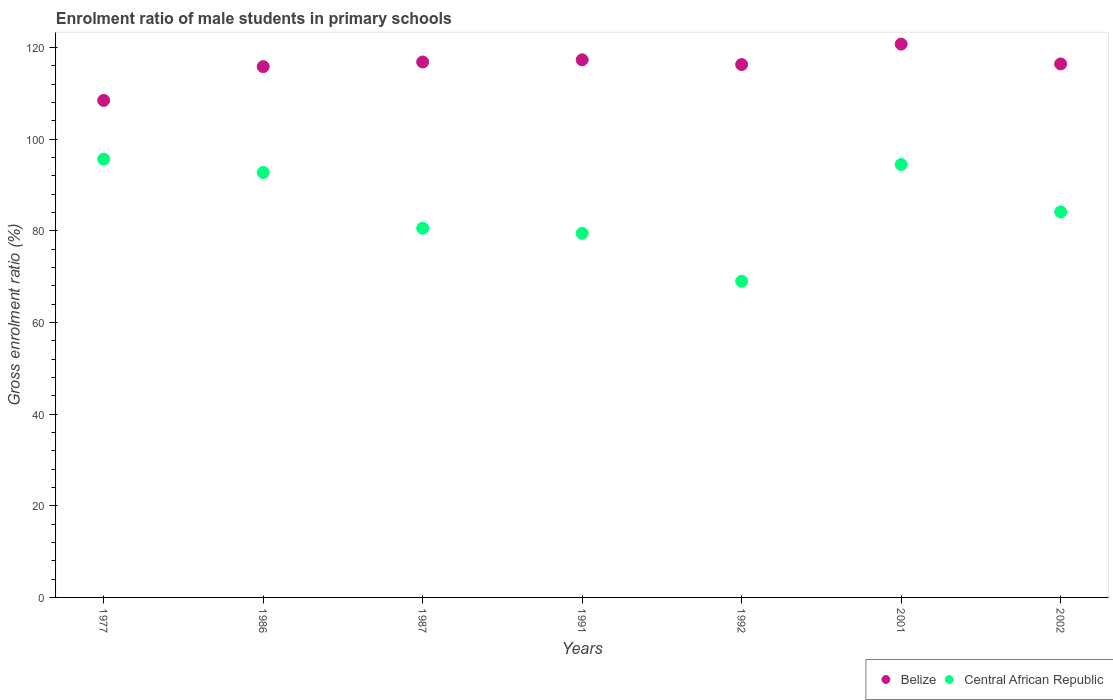What is the enrolment ratio of male students in primary schools in Belize in 2002?
Your answer should be compact. 116.45. Across all years, what is the maximum enrolment ratio of male students in primary schools in Central African Republic?
Make the answer very short. 95.67. Across all years, what is the minimum enrolment ratio of male students in primary schools in Belize?
Your answer should be compact. 108.48. In which year was the enrolment ratio of male students in primary schools in Central African Republic minimum?
Make the answer very short. 1992. What is the total enrolment ratio of male students in primary schools in Central African Republic in the graph?
Your answer should be very brief. 596.15. What is the difference between the enrolment ratio of male students in primary schools in Central African Republic in 1987 and that in 2002?
Offer a terse response. -3.56. What is the difference between the enrolment ratio of male students in primary schools in Belize in 1991 and the enrolment ratio of male students in primary schools in Central African Republic in 1992?
Offer a very short reply. 48.32. What is the average enrolment ratio of male students in primary schools in Belize per year?
Give a very brief answer. 116.01. In the year 1977, what is the difference between the enrolment ratio of male students in primary schools in Central African Republic and enrolment ratio of male students in primary schools in Belize?
Offer a terse response. -12.81. In how many years, is the enrolment ratio of male students in primary schools in Central African Republic greater than 52 %?
Make the answer very short. 7. What is the ratio of the enrolment ratio of male students in primary schools in Central African Republic in 1992 to that in 2001?
Provide a short and direct response. 0.73. What is the difference between the highest and the second highest enrolment ratio of male students in primary schools in Central African Republic?
Provide a short and direct response. 1.17. What is the difference between the highest and the lowest enrolment ratio of male students in primary schools in Central African Republic?
Ensure brevity in your answer.  26.65. In how many years, is the enrolment ratio of male students in primary schools in Central African Republic greater than the average enrolment ratio of male students in primary schools in Central African Republic taken over all years?
Ensure brevity in your answer.  3. Does the enrolment ratio of male students in primary schools in Belize monotonically increase over the years?
Offer a terse response. No. Is the enrolment ratio of male students in primary schools in Belize strictly less than the enrolment ratio of male students in primary schools in Central African Republic over the years?
Offer a terse response. No. How many dotlines are there?
Offer a very short reply. 2. Are the values on the major ticks of Y-axis written in scientific E-notation?
Make the answer very short. No. Does the graph contain any zero values?
Make the answer very short. No. What is the title of the graph?
Your answer should be very brief. Enrolment ratio of male students in primary schools. Does "Singapore" appear as one of the legend labels in the graph?
Your answer should be compact. No. What is the label or title of the X-axis?
Your answer should be very brief. Years. What is the label or title of the Y-axis?
Your answer should be very brief. Gross enrolment ratio (%). What is the Gross enrolment ratio (%) in Belize in 1977?
Your response must be concise. 108.48. What is the Gross enrolment ratio (%) of Central African Republic in 1977?
Your response must be concise. 95.67. What is the Gross enrolment ratio (%) of Belize in 1986?
Your response must be concise. 115.86. What is the Gross enrolment ratio (%) of Central African Republic in 1986?
Keep it short and to the point. 92.75. What is the Gross enrolment ratio (%) in Belize in 1987?
Keep it short and to the point. 116.87. What is the Gross enrolment ratio (%) of Central African Republic in 1987?
Your response must be concise. 80.58. What is the Gross enrolment ratio (%) in Belize in 1991?
Make the answer very short. 117.34. What is the Gross enrolment ratio (%) in Central African Republic in 1991?
Your answer should be very brief. 79.48. What is the Gross enrolment ratio (%) of Belize in 1992?
Provide a short and direct response. 116.31. What is the Gross enrolment ratio (%) in Central African Republic in 1992?
Make the answer very short. 69.02. What is the Gross enrolment ratio (%) of Belize in 2001?
Offer a very short reply. 120.77. What is the Gross enrolment ratio (%) of Central African Republic in 2001?
Your answer should be compact. 94.5. What is the Gross enrolment ratio (%) in Belize in 2002?
Keep it short and to the point. 116.45. What is the Gross enrolment ratio (%) of Central African Republic in 2002?
Your response must be concise. 84.15. Across all years, what is the maximum Gross enrolment ratio (%) in Belize?
Give a very brief answer. 120.77. Across all years, what is the maximum Gross enrolment ratio (%) of Central African Republic?
Make the answer very short. 95.67. Across all years, what is the minimum Gross enrolment ratio (%) in Belize?
Your answer should be compact. 108.48. Across all years, what is the minimum Gross enrolment ratio (%) of Central African Republic?
Your answer should be very brief. 69.02. What is the total Gross enrolment ratio (%) of Belize in the graph?
Offer a very short reply. 812.08. What is the total Gross enrolment ratio (%) in Central African Republic in the graph?
Give a very brief answer. 596.15. What is the difference between the Gross enrolment ratio (%) of Belize in 1977 and that in 1986?
Your answer should be compact. -7.37. What is the difference between the Gross enrolment ratio (%) in Central African Republic in 1977 and that in 1986?
Give a very brief answer. 2.92. What is the difference between the Gross enrolment ratio (%) of Belize in 1977 and that in 1987?
Your answer should be compact. -8.39. What is the difference between the Gross enrolment ratio (%) in Central African Republic in 1977 and that in 1987?
Your answer should be very brief. 15.08. What is the difference between the Gross enrolment ratio (%) of Belize in 1977 and that in 1991?
Your answer should be very brief. -8.86. What is the difference between the Gross enrolment ratio (%) of Central African Republic in 1977 and that in 1991?
Make the answer very short. 16.19. What is the difference between the Gross enrolment ratio (%) in Belize in 1977 and that in 1992?
Offer a terse response. -7.83. What is the difference between the Gross enrolment ratio (%) of Central African Republic in 1977 and that in 1992?
Keep it short and to the point. 26.65. What is the difference between the Gross enrolment ratio (%) in Belize in 1977 and that in 2001?
Keep it short and to the point. -12.29. What is the difference between the Gross enrolment ratio (%) of Central African Republic in 1977 and that in 2001?
Provide a succinct answer. 1.17. What is the difference between the Gross enrolment ratio (%) of Belize in 1977 and that in 2002?
Your response must be concise. -7.97. What is the difference between the Gross enrolment ratio (%) in Central African Republic in 1977 and that in 2002?
Keep it short and to the point. 11.52. What is the difference between the Gross enrolment ratio (%) in Belize in 1986 and that in 1987?
Keep it short and to the point. -1.01. What is the difference between the Gross enrolment ratio (%) of Central African Republic in 1986 and that in 1987?
Make the answer very short. 12.17. What is the difference between the Gross enrolment ratio (%) of Belize in 1986 and that in 1991?
Your response must be concise. -1.49. What is the difference between the Gross enrolment ratio (%) in Central African Republic in 1986 and that in 1991?
Give a very brief answer. 13.27. What is the difference between the Gross enrolment ratio (%) of Belize in 1986 and that in 1992?
Offer a terse response. -0.45. What is the difference between the Gross enrolment ratio (%) of Central African Republic in 1986 and that in 1992?
Give a very brief answer. 23.74. What is the difference between the Gross enrolment ratio (%) of Belize in 1986 and that in 2001?
Provide a short and direct response. -4.92. What is the difference between the Gross enrolment ratio (%) in Central African Republic in 1986 and that in 2001?
Ensure brevity in your answer.  -1.74. What is the difference between the Gross enrolment ratio (%) in Belize in 1986 and that in 2002?
Offer a very short reply. -0.59. What is the difference between the Gross enrolment ratio (%) in Central African Republic in 1986 and that in 2002?
Your response must be concise. 8.6. What is the difference between the Gross enrolment ratio (%) in Belize in 1987 and that in 1991?
Offer a very short reply. -0.47. What is the difference between the Gross enrolment ratio (%) of Central African Republic in 1987 and that in 1991?
Ensure brevity in your answer.  1.1. What is the difference between the Gross enrolment ratio (%) in Belize in 1987 and that in 1992?
Provide a short and direct response. 0.56. What is the difference between the Gross enrolment ratio (%) of Central African Republic in 1987 and that in 1992?
Your answer should be compact. 11.57. What is the difference between the Gross enrolment ratio (%) in Belize in 1987 and that in 2001?
Your response must be concise. -3.9. What is the difference between the Gross enrolment ratio (%) of Central African Republic in 1987 and that in 2001?
Your answer should be compact. -13.91. What is the difference between the Gross enrolment ratio (%) of Belize in 1987 and that in 2002?
Provide a short and direct response. 0.42. What is the difference between the Gross enrolment ratio (%) of Central African Republic in 1987 and that in 2002?
Ensure brevity in your answer.  -3.56. What is the difference between the Gross enrolment ratio (%) of Belize in 1991 and that in 1992?
Keep it short and to the point. 1.03. What is the difference between the Gross enrolment ratio (%) of Central African Republic in 1991 and that in 1992?
Provide a short and direct response. 10.47. What is the difference between the Gross enrolment ratio (%) of Belize in 1991 and that in 2001?
Offer a very short reply. -3.43. What is the difference between the Gross enrolment ratio (%) in Central African Republic in 1991 and that in 2001?
Give a very brief answer. -15.01. What is the difference between the Gross enrolment ratio (%) of Belize in 1991 and that in 2002?
Give a very brief answer. 0.89. What is the difference between the Gross enrolment ratio (%) in Central African Republic in 1991 and that in 2002?
Your answer should be compact. -4.67. What is the difference between the Gross enrolment ratio (%) in Belize in 1992 and that in 2001?
Your answer should be compact. -4.46. What is the difference between the Gross enrolment ratio (%) in Central African Republic in 1992 and that in 2001?
Give a very brief answer. -25.48. What is the difference between the Gross enrolment ratio (%) in Belize in 1992 and that in 2002?
Give a very brief answer. -0.14. What is the difference between the Gross enrolment ratio (%) of Central African Republic in 1992 and that in 2002?
Provide a succinct answer. -15.13. What is the difference between the Gross enrolment ratio (%) in Belize in 2001 and that in 2002?
Your answer should be very brief. 4.32. What is the difference between the Gross enrolment ratio (%) in Central African Republic in 2001 and that in 2002?
Ensure brevity in your answer.  10.35. What is the difference between the Gross enrolment ratio (%) in Belize in 1977 and the Gross enrolment ratio (%) in Central African Republic in 1986?
Offer a terse response. 15.73. What is the difference between the Gross enrolment ratio (%) in Belize in 1977 and the Gross enrolment ratio (%) in Central African Republic in 1987?
Offer a very short reply. 27.9. What is the difference between the Gross enrolment ratio (%) in Belize in 1977 and the Gross enrolment ratio (%) in Central African Republic in 1991?
Ensure brevity in your answer.  29. What is the difference between the Gross enrolment ratio (%) in Belize in 1977 and the Gross enrolment ratio (%) in Central African Republic in 1992?
Offer a very short reply. 39.47. What is the difference between the Gross enrolment ratio (%) of Belize in 1977 and the Gross enrolment ratio (%) of Central African Republic in 2001?
Provide a succinct answer. 13.99. What is the difference between the Gross enrolment ratio (%) in Belize in 1977 and the Gross enrolment ratio (%) in Central African Republic in 2002?
Ensure brevity in your answer.  24.33. What is the difference between the Gross enrolment ratio (%) of Belize in 1986 and the Gross enrolment ratio (%) of Central African Republic in 1987?
Provide a succinct answer. 35.27. What is the difference between the Gross enrolment ratio (%) in Belize in 1986 and the Gross enrolment ratio (%) in Central African Republic in 1991?
Provide a succinct answer. 36.37. What is the difference between the Gross enrolment ratio (%) of Belize in 1986 and the Gross enrolment ratio (%) of Central African Republic in 1992?
Offer a very short reply. 46.84. What is the difference between the Gross enrolment ratio (%) in Belize in 1986 and the Gross enrolment ratio (%) in Central African Republic in 2001?
Provide a short and direct response. 21.36. What is the difference between the Gross enrolment ratio (%) in Belize in 1986 and the Gross enrolment ratio (%) in Central African Republic in 2002?
Give a very brief answer. 31.71. What is the difference between the Gross enrolment ratio (%) in Belize in 1987 and the Gross enrolment ratio (%) in Central African Republic in 1991?
Give a very brief answer. 37.39. What is the difference between the Gross enrolment ratio (%) of Belize in 1987 and the Gross enrolment ratio (%) of Central African Republic in 1992?
Keep it short and to the point. 47.85. What is the difference between the Gross enrolment ratio (%) of Belize in 1987 and the Gross enrolment ratio (%) of Central African Republic in 2001?
Your response must be concise. 22.37. What is the difference between the Gross enrolment ratio (%) in Belize in 1987 and the Gross enrolment ratio (%) in Central African Republic in 2002?
Offer a terse response. 32.72. What is the difference between the Gross enrolment ratio (%) in Belize in 1991 and the Gross enrolment ratio (%) in Central African Republic in 1992?
Offer a very short reply. 48.32. What is the difference between the Gross enrolment ratio (%) of Belize in 1991 and the Gross enrolment ratio (%) of Central African Republic in 2001?
Give a very brief answer. 22.85. What is the difference between the Gross enrolment ratio (%) of Belize in 1991 and the Gross enrolment ratio (%) of Central African Republic in 2002?
Give a very brief answer. 33.19. What is the difference between the Gross enrolment ratio (%) in Belize in 1992 and the Gross enrolment ratio (%) in Central African Republic in 2001?
Your answer should be very brief. 21.81. What is the difference between the Gross enrolment ratio (%) in Belize in 1992 and the Gross enrolment ratio (%) in Central African Republic in 2002?
Your response must be concise. 32.16. What is the difference between the Gross enrolment ratio (%) in Belize in 2001 and the Gross enrolment ratio (%) in Central African Republic in 2002?
Your answer should be compact. 36.62. What is the average Gross enrolment ratio (%) of Belize per year?
Provide a short and direct response. 116.01. What is the average Gross enrolment ratio (%) in Central African Republic per year?
Make the answer very short. 85.16. In the year 1977, what is the difference between the Gross enrolment ratio (%) of Belize and Gross enrolment ratio (%) of Central African Republic?
Offer a terse response. 12.81. In the year 1986, what is the difference between the Gross enrolment ratio (%) in Belize and Gross enrolment ratio (%) in Central African Republic?
Offer a very short reply. 23.1. In the year 1987, what is the difference between the Gross enrolment ratio (%) of Belize and Gross enrolment ratio (%) of Central African Republic?
Your answer should be very brief. 36.29. In the year 1991, what is the difference between the Gross enrolment ratio (%) of Belize and Gross enrolment ratio (%) of Central African Republic?
Your answer should be compact. 37.86. In the year 1992, what is the difference between the Gross enrolment ratio (%) of Belize and Gross enrolment ratio (%) of Central African Republic?
Provide a succinct answer. 47.29. In the year 2001, what is the difference between the Gross enrolment ratio (%) of Belize and Gross enrolment ratio (%) of Central African Republic?
Ensure brevity in your answer.  26.28. In the year 2002, what is the difference between the Gross enrolment ratio (%) of Belize and Gross enrolment ratio (%) of Central African Republic?
Your answer should be compact. 32.3. What is the ratio of the Gross enrolment ratio (%) of Belize in 1977 to that in 1986?
Provide a succinct answer. 0.94. What is the ratio of the Gross enrolment ratio (%) of Central African Republic in 1977 to that in 1986?
Provide a succinct answer. 1.03. What is the ratio of the Gross enrolment ratio (%) of Belize in 1977 to that in 1987?
Offer a terse response. 0.93. What is the ratio of the Gross enrolment ratio (%) in Central African Republic in 1977 to that in 1987?
Keep it short and to the point. 1.19. What is the ratio of the Gross enrolment ratio (%) of Belize in 1977 to that in 1991?
Give a very brief answer. 0.92. What is the ratio of the Gross enrolment ratio (%) in Central African Republic in 1977 to that in 1991?
Keep it short and to the point. 1.2. What is the ratio of the Gross enrolment ratio (%) in Belize in 1977 to that in 1992?
Provide a succinct answer. 0.93. What is the ratio of the Gross enrolment ratio (%) in Central African Republic in 1977 to that in 1992?
Your answer should be compact. 1.39. What is the ratio of the Gross enrolment ratio (%) in Belize in 1977 to that in 2001?
Your answer should be compact. 0.9. What is the ratio of the Gross enrolment ratio (%) in Central African Republic in 1977 to that in 2001?
Your answer should be compact. 1.01. What is the ratio of the Gross enrolment ratio (%) of Belize in 1977 to that in 2002?
Give a very brief answer. 0.93. What is the ratio of the Gross enrolment ratio (%) in Central African Republic in 1977 to that in 2002?
Provide a succinct answer. 1.14. What is the ratio of the Gross enrolment ratio (%) of Central African Republic in 1986 to that in 1987?
Offer a terse response. 1.15. What is the ratio of the Gross enrolment ratio (%) in Belize in 1986 to that in 1991?
Provide a short and direct response. 0.99. What is the ratio of the Gross enrolment ratio (%) in Central African Republic in 1986 to that in 1991?
Keep it short and to the point. 1.17. What is the ratio of the Gross enrolment ratio (%) of Belize in 1986 to that in 1992?
Your response must be concise. 1. What is the ratio of the Gross enrolment ratio (%) of Central African Republic in 1986 to that in 1992?
Provide a succinct answer. 1.34. What is the ratio of the Gross enrolment ratio (%) in Belize in 1986 to that in 2001?
Offer a terse response. 0.96. What is the ratio of the Gross enrolment ratio (%) of Central African Republic in 1986 to that in 2001?
Provide a short and direct response. 0.98. What is the ratio of the Gross enrolment ratio (%) of Central African Republic in 1986 to that in 2002?
Make the answer very short. 1.1. What is the ratio of the Gross enrolment ratio (%) in Central African Republic in 1987 to that in 1991?
Make the answer very short. 1.01. What is the ratio of the Gross enrolment ratio (%) in Belize in 1987 to that in 1992?
Your response must be concise. 1. What is the ratio of the Gross enrolment ratio (%) of Central African Republic in 1987 to that in 1992?
Your answer should be compact. 1.17. What is the ratio of the Gross enrolment ratio (%) in Belize in 1987 to that in 2001?
Provide a succinct answer. 0.97. What is the ratio of the Gross enrolment ratio (%) in Central African Republic in 1987 to that in 2001?
Provide a succinct answer. 0.85. What is the ratio of the Gross enrolment ratio (%) of Central African Republic in 1987 to that in 2002?
Give a very brief answer. 0.96. What is the ratio of the Gross enrolment ratio (%) of Belize in 1991 to that in 1992?
Offer a terse response. 1.01. What is the ratio of the Gross enrolment ratio (%) in Central African Republic in 1991 to that in 1992?
Make the answer very short. 1.15. What is the ratio of the Gross enrolment ratio (%) in Belize in 1991 to that in 2001?
Your response must be concise. 0.97. What is the ratio of the Gross enrolment ratio (%) of Central African Republic in 1991 to that in 2001?
Your answer should be very brief. 0.84. What is the ratio of the Gross enrolment ratio (%) in Belize in 1991 to that in 2002?
Ensure brevity in your answer.  1.01. What is the ratio of the Gross enrolment ratio (%) of Central African Republic in 1991 to that in 2002?
Offer a terse response. 0.94. What is the ratio of the Gross enrolment ratio (%) in Belize in 1992 to that in 2001?
Provide a succinct answer. 0.96. What is the ratio of the Gross enrolment ratio (%) of Central African Republic in 1992 to that in 2001?
Give a very brief answer. 0.73. What is the ratio of the Gross enrolment ratio (%) of Central African Republic in 1992 to that in 2002?
Offer a terse response. 0.82. What is the ratio of the Gross enrolment ratio (%) of Belize in 2001 to that in 2002?
Your answer should be very brief. 1.04. What is the ratio of the Gross enrolment ratio (%) in Central African Republic in 2001 to that in 2002?
Provide a short and direct response. 1.12. What is the difference between the highest and the second highest Gross enrolment ratio (%) in Belize?
Make the answer very short. 3.43. What is the difference between the highest and the second highest Gross enrolment ratio (%) in Central African Republic?
Offer a terse response. 1.17. What is the difference between the highest and the lowest Gross enrolment ratio (%) of Belize?
Provide a succinct answer. 12.29. What is the difference between the highest and the lowest Gross enrolment ratio (%) of Central African Republic?
Give a very brief answer. 26.65. 